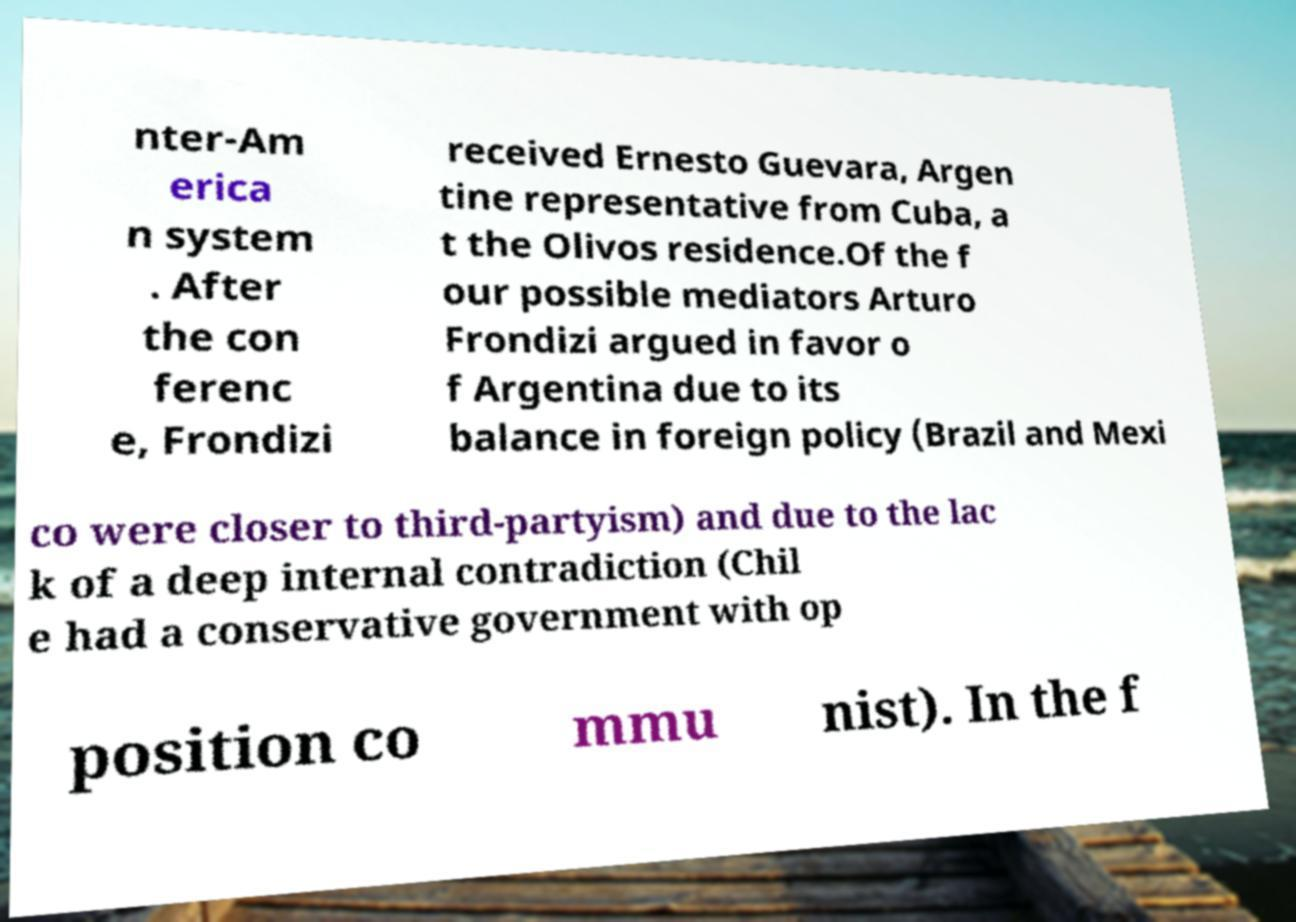Can you accurately transcribe the text from the provided image for me? nter-Am erica n system . After the con ferenc e, Frondizi received Ernesto Guevara, Argen tine representative from Cuba, a t the Olivos residence.Of the f our possible mediators Arturo Frondizi argued in favor o f Argentina due to its balance in foreign policy (Brazil and Mexi co were closer to third-partyism) and due to the lac k of a deep internal contradiction (Chil e had a conservative government with op position co mmu nist). In the f 